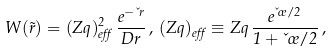Convert formula to latex. <formula><loc_0><loc_0><loc_500><loc_500>W ( \vec { r } ) = ( Z q ) _ { e f f } ^ { 2 } \, \frac { e ^ { - \kappa r } } { D r } \, , \, ( Z q ) _ { e f f } \equiv Z q \, \frac { e ^ { \kappa \sigma / 2 } } { 1 + \kappa \sigma / 2 } \, ,</formula> 